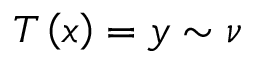Convert formula to latex. <formula><loc_0><loc_0><loc_500><loc_500>T \left ( x \right ) = y \sim \nu</formula> 